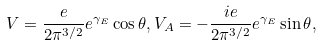<formula> <loc_0><loc_0><loc_500><loc_500>V = \frac { e } { 2 \pi ^ { 3 / 2 } } e ^ { \gamma _ { E } } \cos \theta , V _ { A } = - \frac { i e } { 2 \pi ^ { 3 / 2 } } e ^ { \gamma _ { E } } \sin \theta ,</formula> 